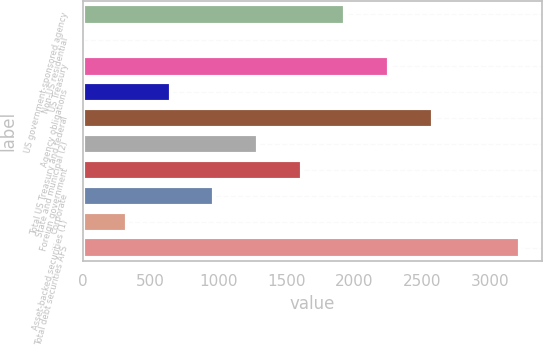Convert chart. <chart><loc_0><loc_0><loc_500><loc_500><bar_chart><fcel>US government-sponsored agency<fcel>Non-US residential<fcel>US Treasury<fcel>Agency obligations<fcel>Total US Treasury and federal<fcel>State and municipal (2)<fcel>Foreign government<fcel>Corporate<fcel>Asset-backed securities (1)<fcel>Total debt securities AFS<nl><fcel>1932.8<fcel>2<fcel>2254.6<fcel>645.6<fcel>2576.4<fcel>1289.2<fcel>1611<fcel>967.4<fcel>323.8<fcel>3220<nl></chart> 